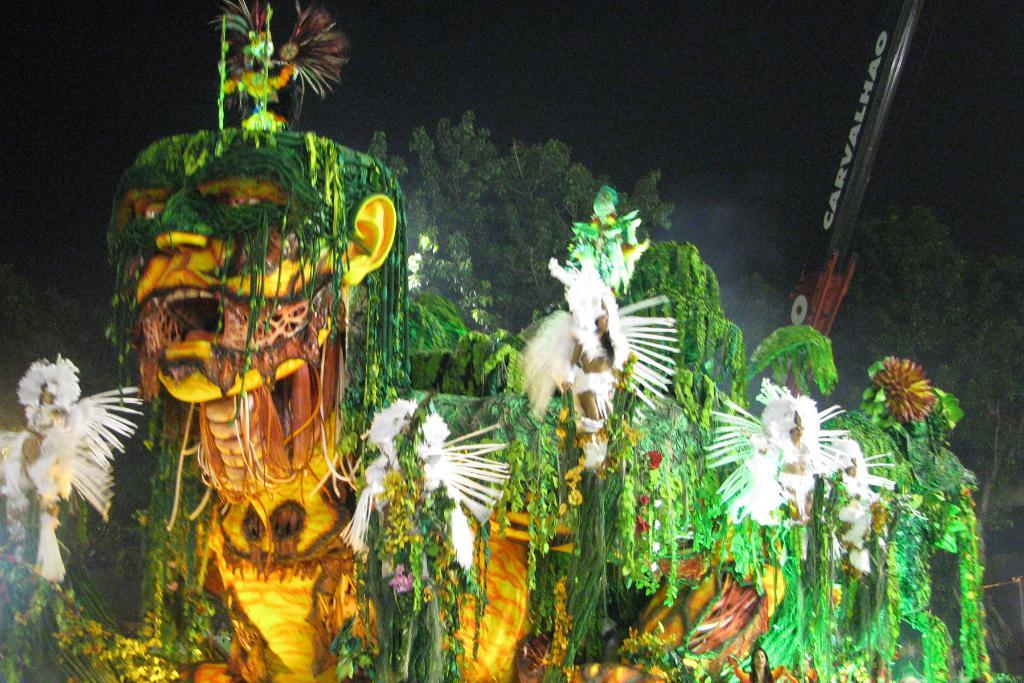What type of event is taking place in the image? The image depicts a Chinese carnival. What are the people wearing at the event? There are groups of people in fancy dresses. What type of natural elements can be seen in the image? There are trees in the image. How would you describe the lighting in the image? The background of the image is dark. Can you read the note that is hanging from the moon in the image? There is no note or moon present in the image. What type of request is being made by the person standing next to the tree in the image? There is no person standing next to the tree making a request in the image. 